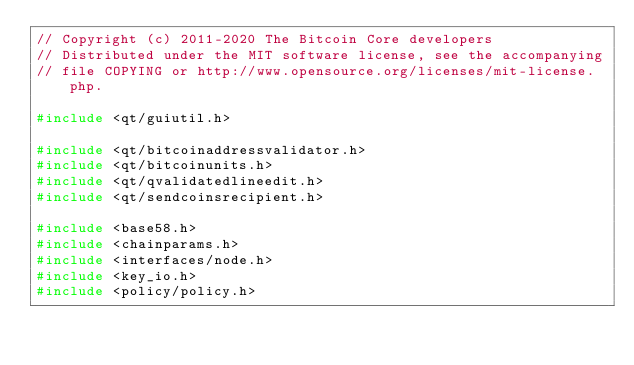Convert code to text. <code><loc_0><loc_0><loc_500><loc_500><_C++_>// Copyright (c) 2011-2020 The Bitcoin Core developers
// Distributed under the MIT software license, see the accompanying
// file COPYING or http://www.opensource.org/licenses/mit-license.php.

#include <qt/guiutil.h>

#include <qt/bitcoinaddressvalidator.h>
#include <qt/bitcoinunits.h>
#include <qt/qvalidatedlineedit.h>
#include <qt/sendcoinsrecipient.h>

#include <base58.h>
#include <chainparams.h>
#include <interfaces/node.h>
#include <key_io.h>
#include <policy/policy.h></code> 